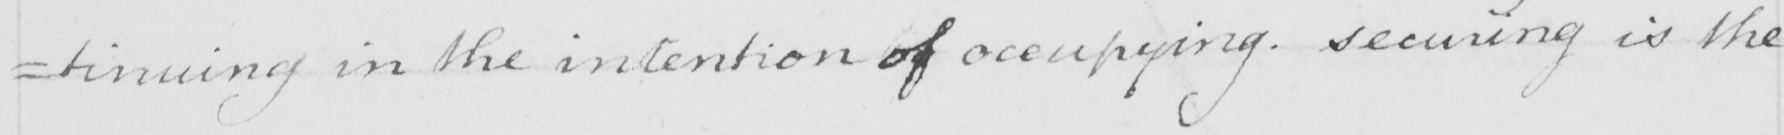Transcribe the text shown in this historical manuscript line. =tinuing in the intention of occupying . Securing is the 